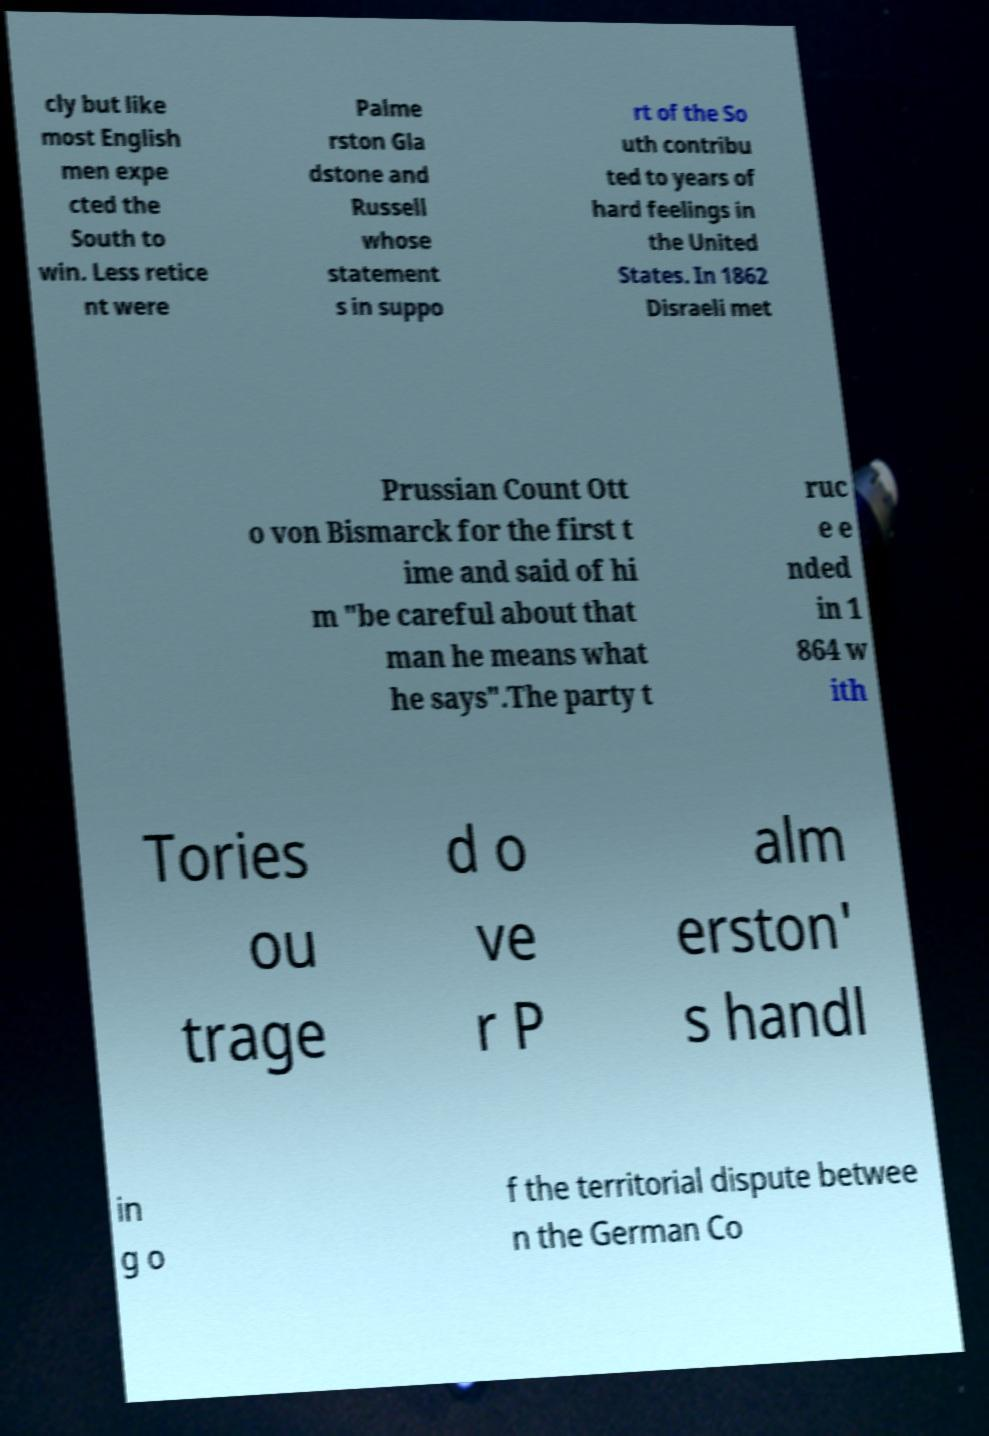Could you extract and type out the text from this image? cly but like most English men expe cted the South to win. Less retice nt were Palme rston Gla dstone and Russell whose statement s in suppo rt of the So uth contribu ted to years of hard feelings in the United States. In 1862 Disraeli met Prussian Count Ott o von Bismarck for the first t ime and said of hi m "be careful about that man he means what he says".The party t ruc e e nded in 1 864 w ith Tories ou trage d o ve r P alm erston' s handl in g o f the territorial dispute betwee n the German Co 